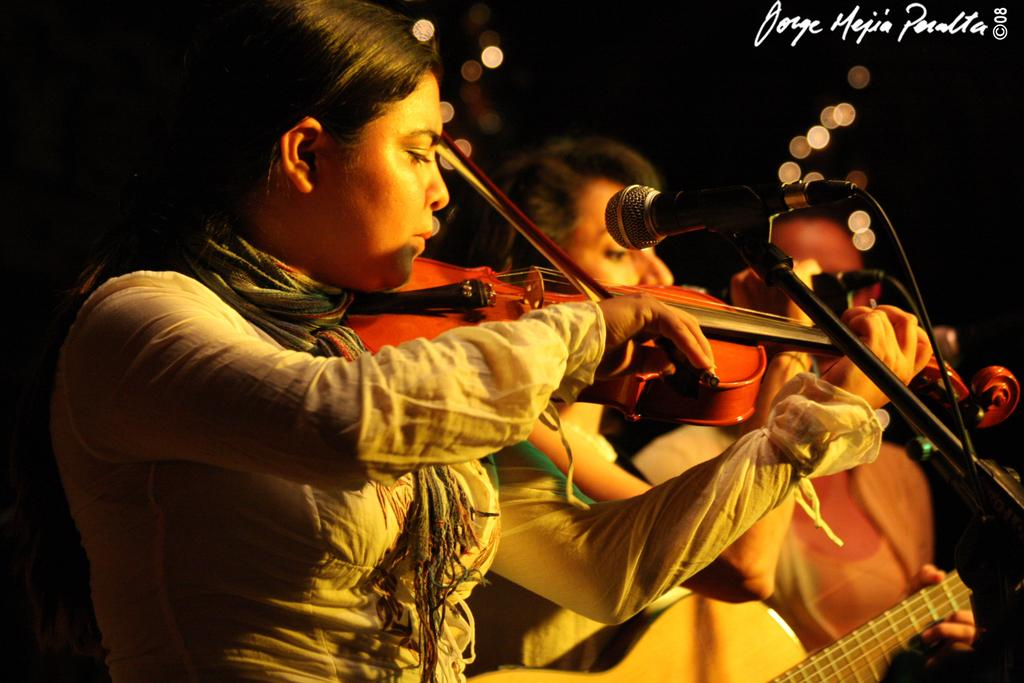What is the woman in the image doing? The woman is playing a violin in the image. What can be seen near the woman? There is a microphone near the woman. How many women are in the image? There are two women in the image. What is the person sitting beside the second woman doing? The provided facts do not specify what the person sitting beside the second woman is doing. What type of apparel is the woman wearing on her finger while playing the violin? There is no ring or any other type of apparel visible on the woman's finger while she is playing the violin in the image. 